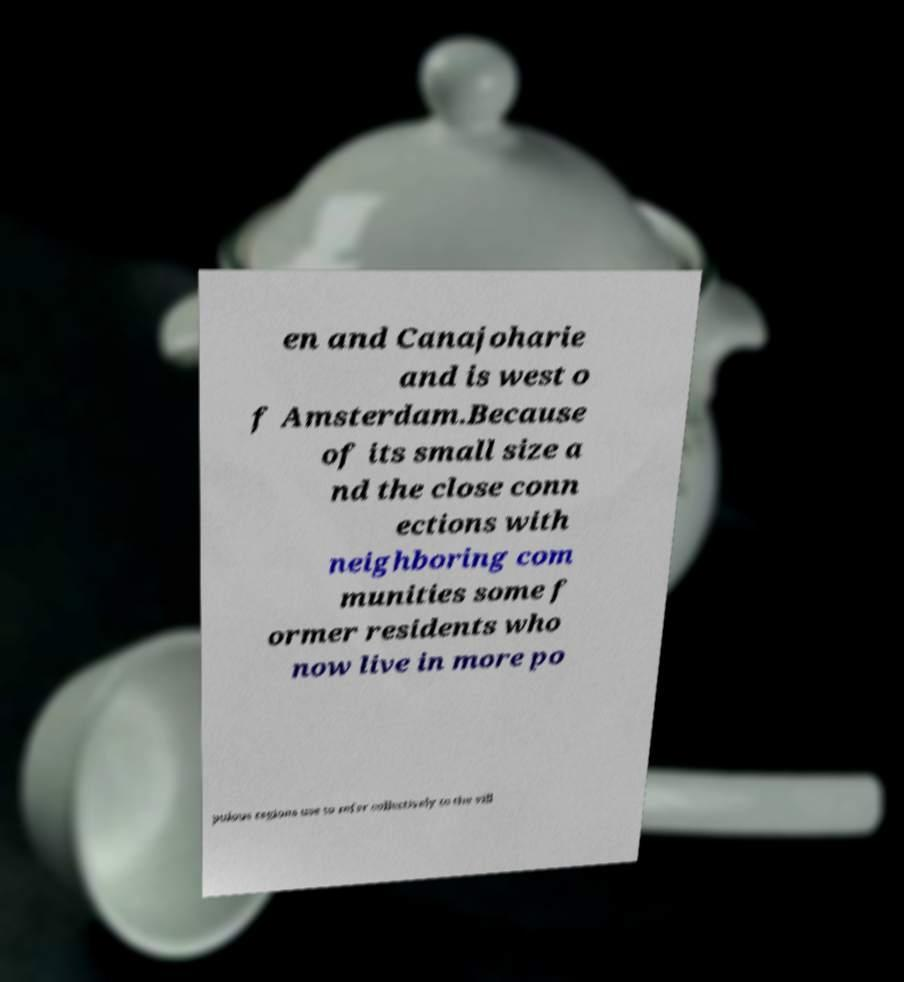There's text embedded in this image that I need extracted. Can you transcribe it verbatim? en and Canajoharie and is west o f Amsterdam.Because of its small size a nd the close conn ections with neighboring com munities some f ormer residents who now live in more po pulous regions use to refer collectively to the vill 